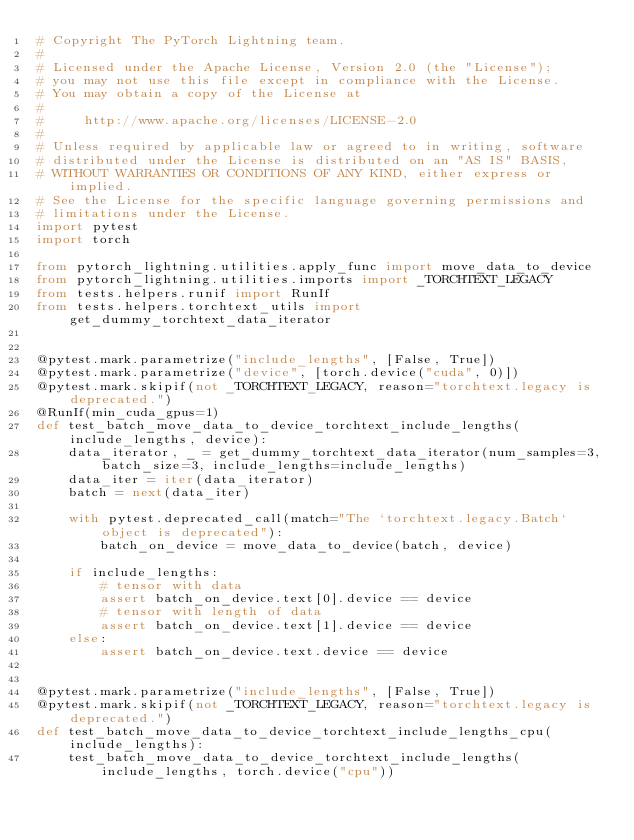<code> <loc_0><loc_0><loc_500><loc_500><_Python_># Copyright The PyTorch Lightning team.
#
# Licensed under the Apache License, Version 2.0 (the "License");
# you may not use this file except in compliance with the License.
# You may obtain a copy of the License at
#
#     http://www.apache.org/licenses/LICENSE-2.0
#
# Unless required by applicable law or agreed to in writing, software
# distributed under the License is distributed on an "AS IS" BASIS,
# WITHOUT WARRANTIES OR CONDITIONS OF ANY KIND, either express or implied.
# See the License for the specific language governing permissions and
# limitations under the License.
import pytest
import torch

from pytorch_lightning.utilities.apply_func import move_data_to_device
from pytorch_lightning.utilities.imports import _TORCHTEXT_LEGACY
from tests.helpers.runif import RunIf
from tests.helpers.torchtext_utils import get_dummy_torchtext_data_iterator


@pytest.mark.parametrize("include_lengths", [False, True])
@pytest.mark.parametrize("device", [torch.device("cuda", 0)])
@pytest.mark.skipif(not _TORCHTEXT_LEGACY, reason="torchtext.legacy is deprecated.")
@RunIf(min_cuda_gpus=1)
def test_batch_move_data_to_device_torchtext_include_lengths(include_lengths, device):
    data_iterator, _ = get_dummy_torchtext_data_iterator(num_samples=3, batch_size=3, include_lengths=include_lengths)
    data_iter = iter(data_iterator)
    batch = next(data_iter)

    with pytest.deprecated_call(match="The `torchtext.legacy.Batch` object is deprecated"):
        batch_on_device = move_data_to_device(batch, device)

    if include_lengths:
        # tensor with data
        assert batch_on_device.text[0].device == device
        # tensor with length of data
        assert batch_on_device.text[1].device == device
    else:
        assert batch_on_device.text.device == device


@pytest.mark.parametrize("include_lengths", [False, True])
@pytest.mark.skipif(not _TORCHTEXT_LEGACY, reason="torchtext.legacy is deprecated.")
def test_batch_move_data_to_device_torchtext_include_lengths_cpu(include_lengths):
    test_batch_move_data_to_device_torchtext_include_lengths(include_lengths, torch.device("cpu"))
</code> 